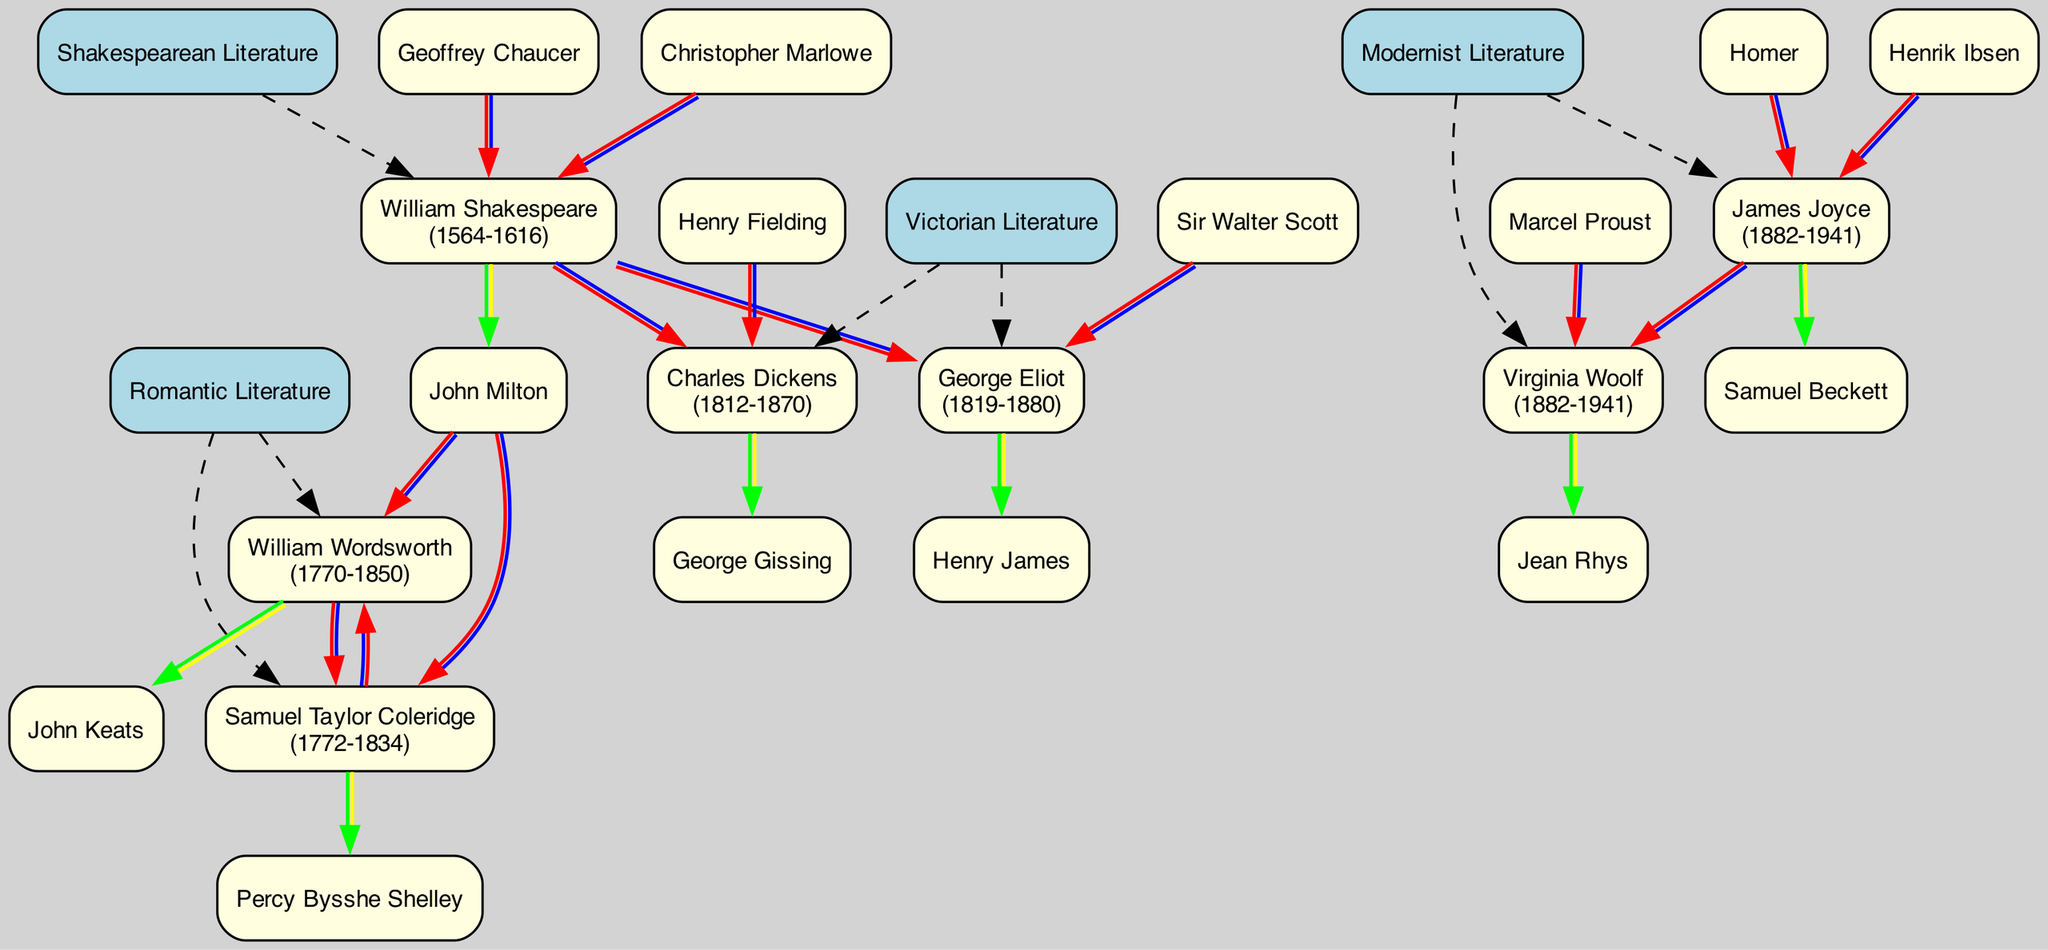What are the two main literary categories evidenced in the family tree? By reviewing the top-level nodes of the family tree, which represent the periods of literary influence, I can see that the categories are Shakespearean Literature and Romantic Literature.
Answer: Shakespearean Literature, Romantic Literature Who is the primary author associated with Victorian Literature? In the section detailing Victorian Literature, the authors listed are Charles Dickens and George Eliot. Charles Dickens is the first author mentioned and is therefore the primary author.
Answer: Charles Dickens How many authors mentored John Keats? Looking at the node for William Wordsworth, who mentored John Keats, I can see that there is only one mentored author listed.
Answer: 1 Which two authors had the same birth year? Upon examining the birth years of the authors, I observe that both Virginia Woolf and James Joyce were born in the year 1882.
Answer: Virginia Woolf, James Joyce Which era does Samuel Taylor Coleridge belong to? By tracing the nodes in the diagram, Samuel Taylor Coleridge is categorized under Romantic Literature.
Answer: Romantic Literature Who influenced Charles Dickens? Reviewing the influences listed under Charles Dickens, I can identify that he was influenced by William Shakespeare and Henry Fielding, making their names the answer.
Answer: William Shakespeare, Henry Fielding How many authors did William Shakespeare mentor? Assessing the node for William Shakespeare, I find that he mentored one author, John Milton.
Answer: 1 Which author is shown to influence both William Wordsworth and Samuel Taylor Coleridge? By looking at their influence lists, I see that John Milton is mentioned as an influence for both authors, confirming that he influenced both.
Answer: John Milton Who are the two authors influenced by John Milton? In the Romantic Literature section, both William Wordsworth and Samuel Taylor Coleridge list John Milton as an influence, signifying that he influenced these two authors.
Answer: William Wordsworth, Samuel Taylor Coleridge 